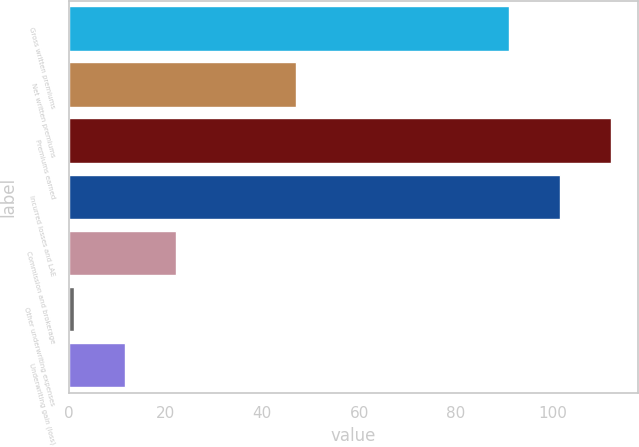Convert chart. <chart><loc_0><loc_0><loc_500><loc_500><bar_chart><fcel>Gross written premiums<fcel>Net written premiums<fcel>Premiums earned<fcel>Incurred losses and LAE<fcel>Commission and brokerage<fcel>Other underwriting expenses<fcel>Underwriting gain (loss)<nl><fcel>90.9<fcel>46.9<fcel>112.02<fcel>101.46<fcel>22.22<fcel>1.1<fcel>11.66<nl></chart> 